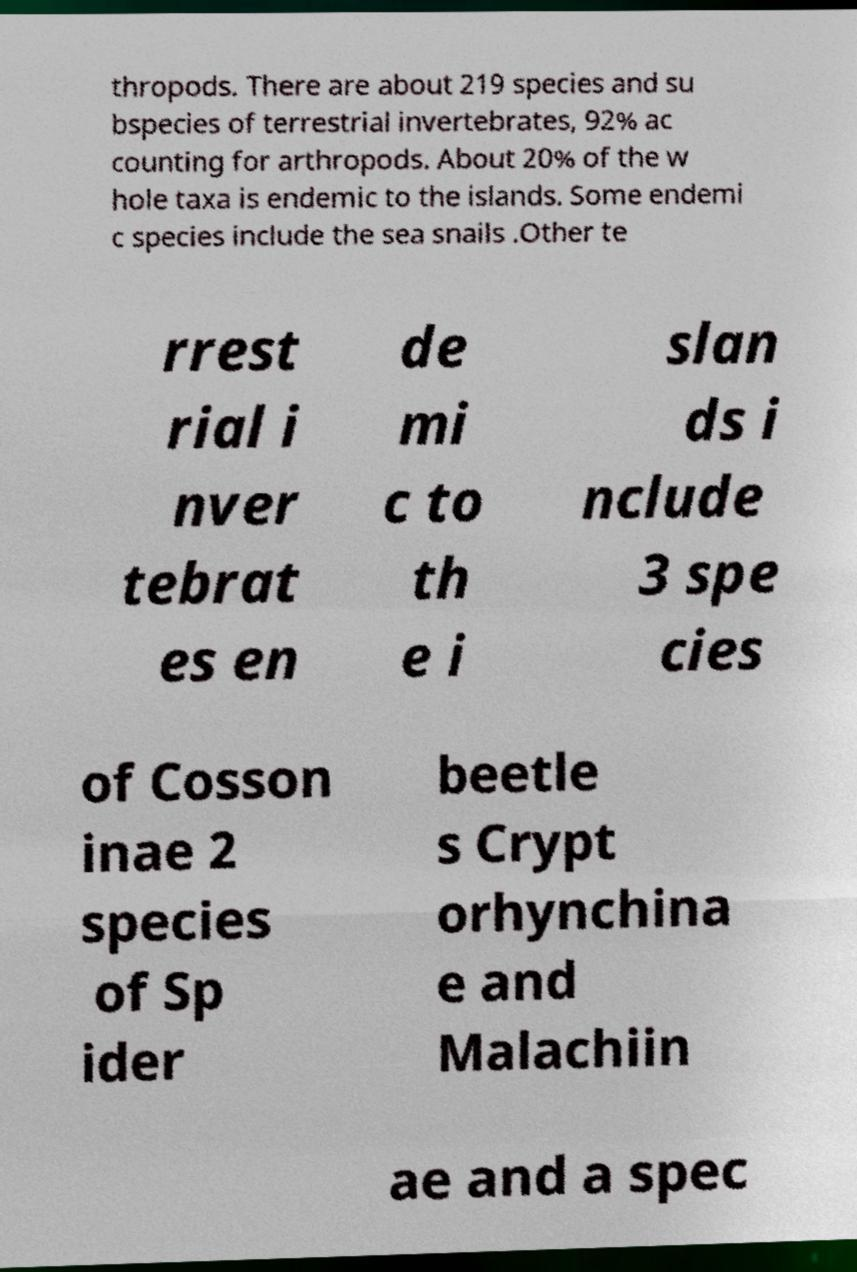There's text embedded in this image that I need extracted. Can you transcribe it verbatim? thropods. There are about 219 species and su bspecies of terrestrial invertebrates, 92% ac counting for arthropods. About 20% of the w hole taxa is endemic to the islands. Some endemi c species include the sea snails .Other te rrest rial i nver tebrat es en de mi c to th e i slan ds i nclude 3 spe cies of Cosson inae 2 species of Sp ider beetle s Crypt orhynchina e and Malachiin ae and a spec 